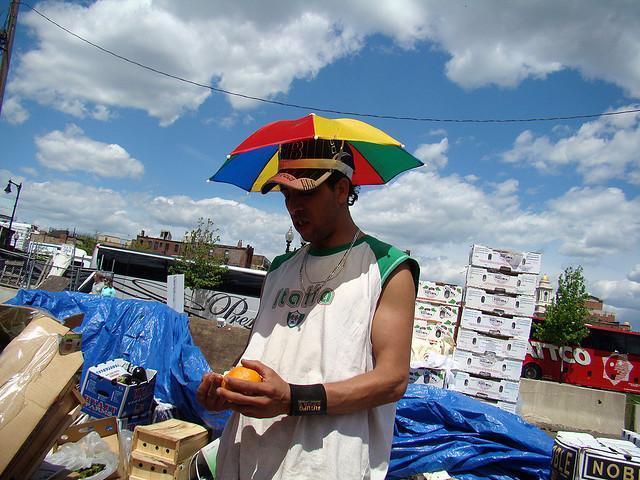How many hats is the man wearing?
Give a very brief answer. 2. How many buses are in the background?
Give a very brief answer. 2. How many buses are visible?
Give a very brief answer. 2. How many elephants can be seen?
Give a very brief answer. 0. 